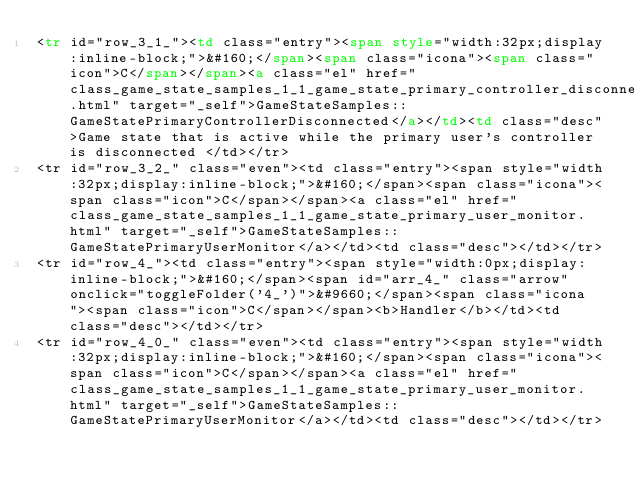<code> <loc_0><loc_0><loc_500><loc_500><_HTML_><tr id="row_3_1_"><td class="entry"><span style="width:32px;display:inline-block;">&#160;</span><span class="icona"><span class="icon">C</span></span><a class="el" href="class_game_state_samples_1_1_game_state_primary_controller_disconnected.html" target="_self">GameStateSamples::GameStatePrimaryControllerDisconnected</a></td><td class="desc">Game state that is active while the primary user's controller is disconnected </td></tr>
<tr id="row_3_2_" class="even"><td class="entry"><span style="width:32px;display:inline-block;">&#160;</span><span class="icona"><span class="icon">C</span></span><a class="el" href="class_game_state_samples_1_1_game_state_primary_user_monitor.html" target="_self">GameStateSamples::GameStatePrimaryUserMonitor</a></td><td class="desc"></td></tr>
<tr id="row_4_"><td class="entry"><span style="width:0px;display:inline-block;">&#160;</span><span id="arr_4_" class="arrow" onclick="toggleFolder('4_')">&#9660;</span><span class="icona"><span class="icon">C</span></span><b>Handler</b></td><td class="desc"></td></tr>
<tr id="row_4_0_" class="even"><td class="entry"><span style="width:32px;display:inline-block;">&#160;</span><span class="icona"><span class="icon">C</span></span><a class="el" href="class_game_state_samples_1_1_game_state_primary_user_monitor.html" target="_self">GameStateSamples::GameStatePrimaryUserMonitor</a></td><td class="desc"></td></tr></code> 